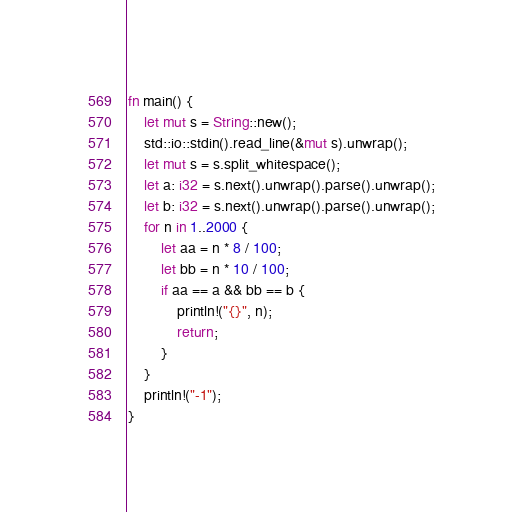<code> <loc_0><loc_0><loc_500><loc_500><_Rust_>fn main() {
	let mut s = String::new();
	std::io::stdin().read_line(&mut s).unwrap();
	let mut s = s.split_whitespace();
	let a: i32 = s.next().unwrap().parse().unwrap();
	let b: i32 = s.next().unwrap().parse().unwrap();
	for n in 1..2000 {
		let aa = n * 8 / 100;
		let bb = n * 10 / 100;
		if aa == a && bb == b {
			println!("{}", n);
			return;
		}
	}
	println!("-1");
}
</code> 